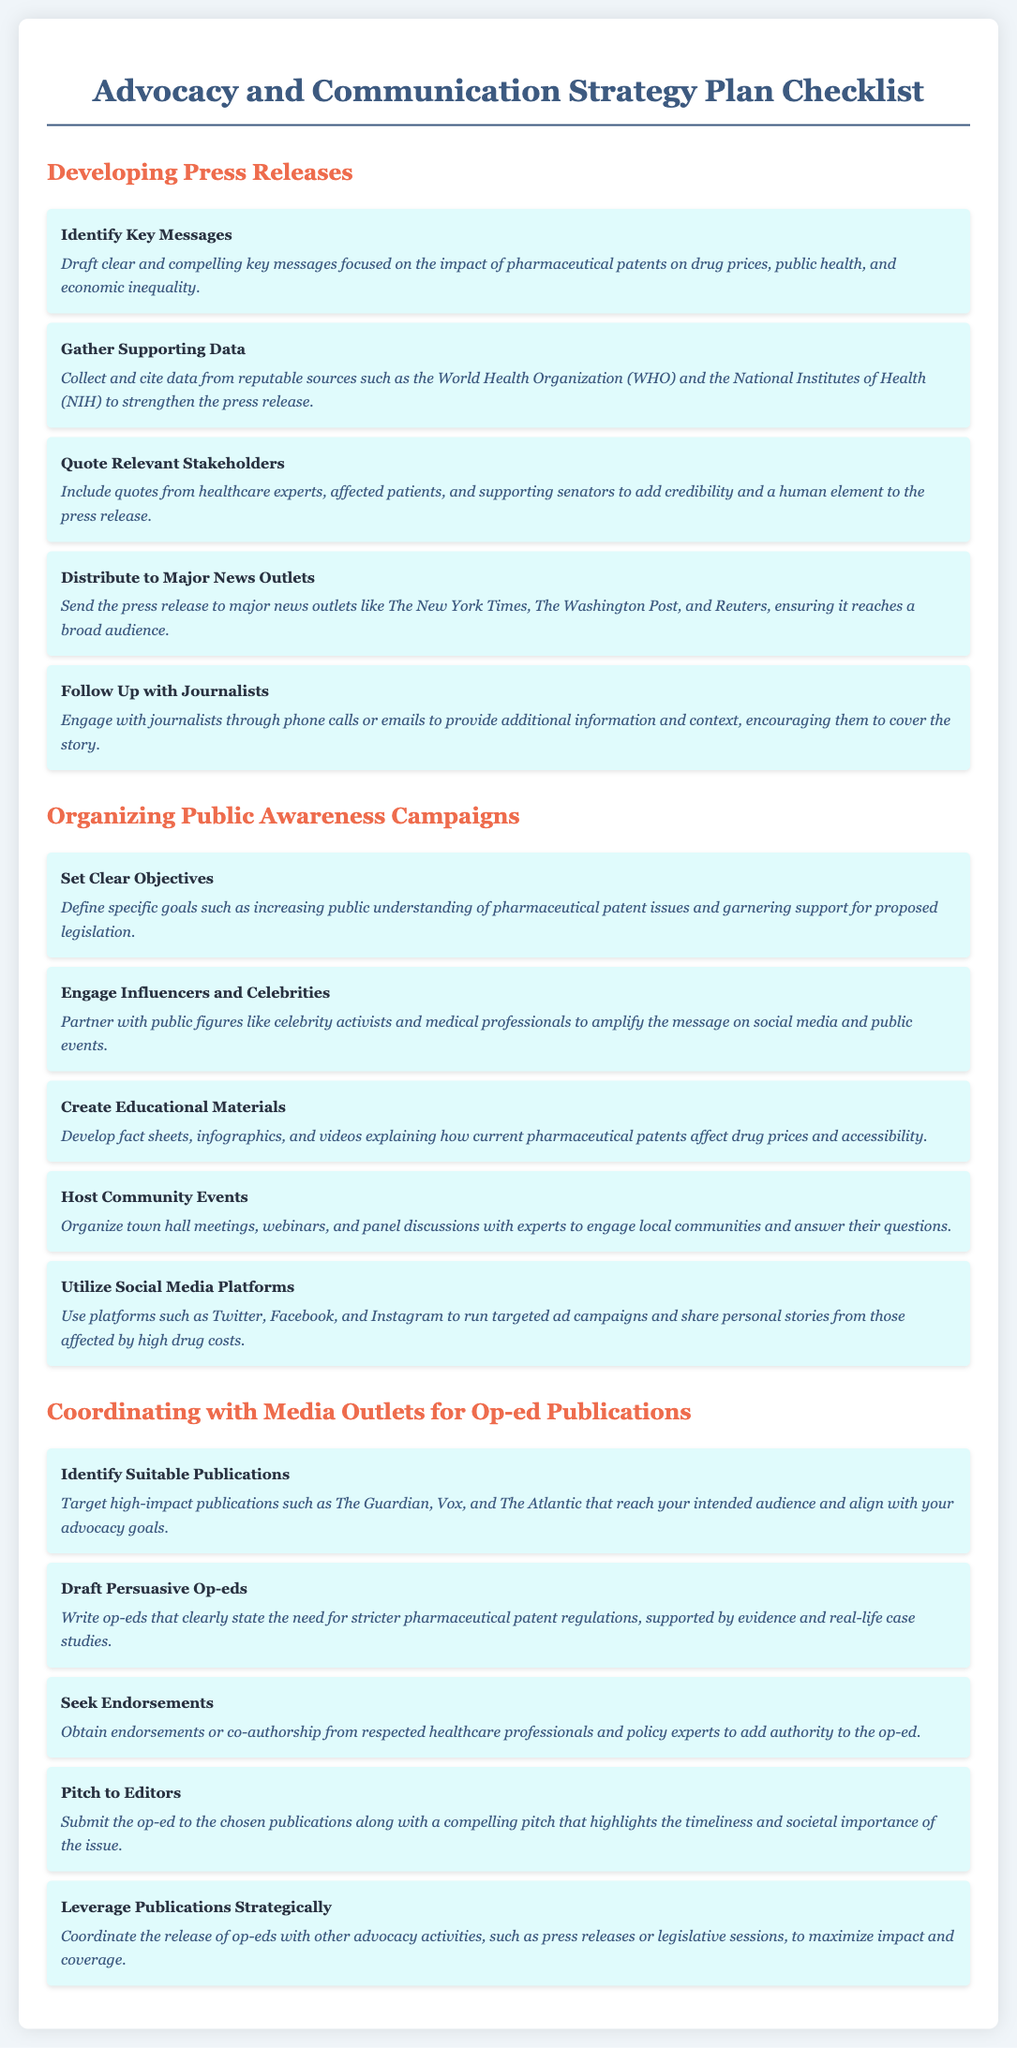what is the title of the document? The title is provided in the heading of the document as specified in the code.
Answer: Advocacy and Communication Strategy Plan Checklist how many key messages are suggested for press releases? The number of suggestions for key messages is indicated by the list items under the "Developing Press Releases" section.
Answer: Five which organization is mentioned as a source for supporting data? A specific organization known for reliable data is referenced in the checklist description for gathering supporting data.
Answer: World Health Organization what is one objective mentioned for public awareness campaigns? The objective is clearly stated in the section that outlines how public awareness campaigns should be structured.
Answer: Increasing public understanding of pharmaceutical patent issues which type of publications should be targeted for op-eds? The checklist specifies what kinds of publications should be considered when drafting op-eds based on their audience reach.
Answer: High-impact publications what is the main focus of the op-eds as stated in the document? The main focus area for the op-ed content is highlighted within the description of what should be included in them.
Answer: Stricter pharmaceutical patent regulations how many recommendations are there for hosting community events? The recommendations can be counted from the section that discusses organizing public awareness campaigns.
Answer: Five what is suggested to include in press releases to add credibility? This suggestion deals with enhancing the believability of the press release as indicated in the relevant checklist item.
Answer: Quotes from healthcare experts what should be coordinated strategically according to the document? The document outlines an important aspect of organizing advocacy efforts for enhanced effect, specifically within the context of publications.
Answer: Release of op-eds 